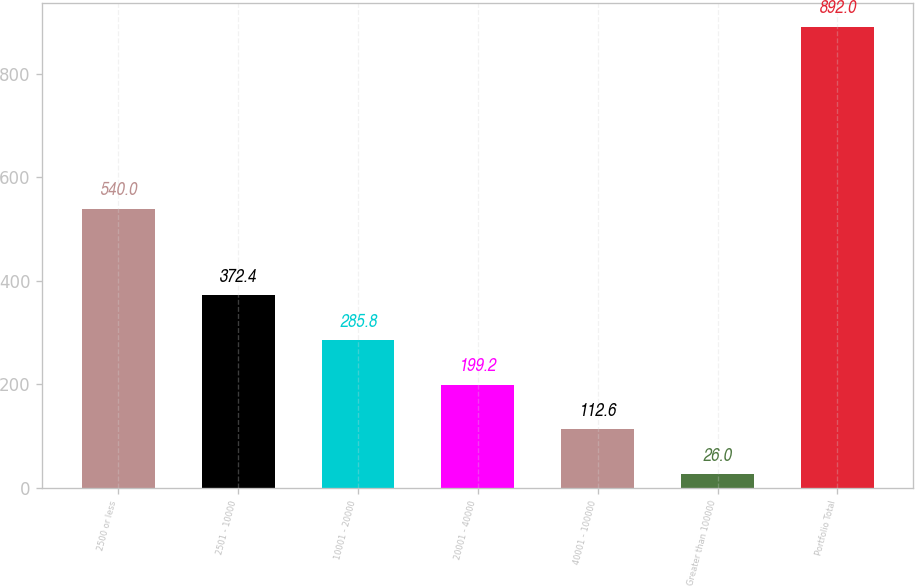Convert chart. <chart><loc_0><loc_0><loc_500><loc_500><bar_chart><fcel>2500 or less<fcel>2501 - 10000<fcel>10001 - 20000<fcel>20001 - 40000<fcel>40001 - 100000<fcel>Greater than 100000<fcel>Portfolio Total<nl><fcel>540<fcel>372.4<fcel>285.8<fcel>199.2<fcel>112.6<fcel>26<fcel>892<nl></chart> 